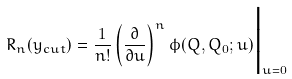<formula> <loc_0><loc_0><loc_500><loc_500>R _ { n } ( y _ { c u t } ) = \frac { 1 } { n ! } \left ( \frac { \partial } { \partial u } \right ) ^ { n } \phi ( Q , Q _ { 0 } ; u ) \Big | _ { u = 0 }</formula> 